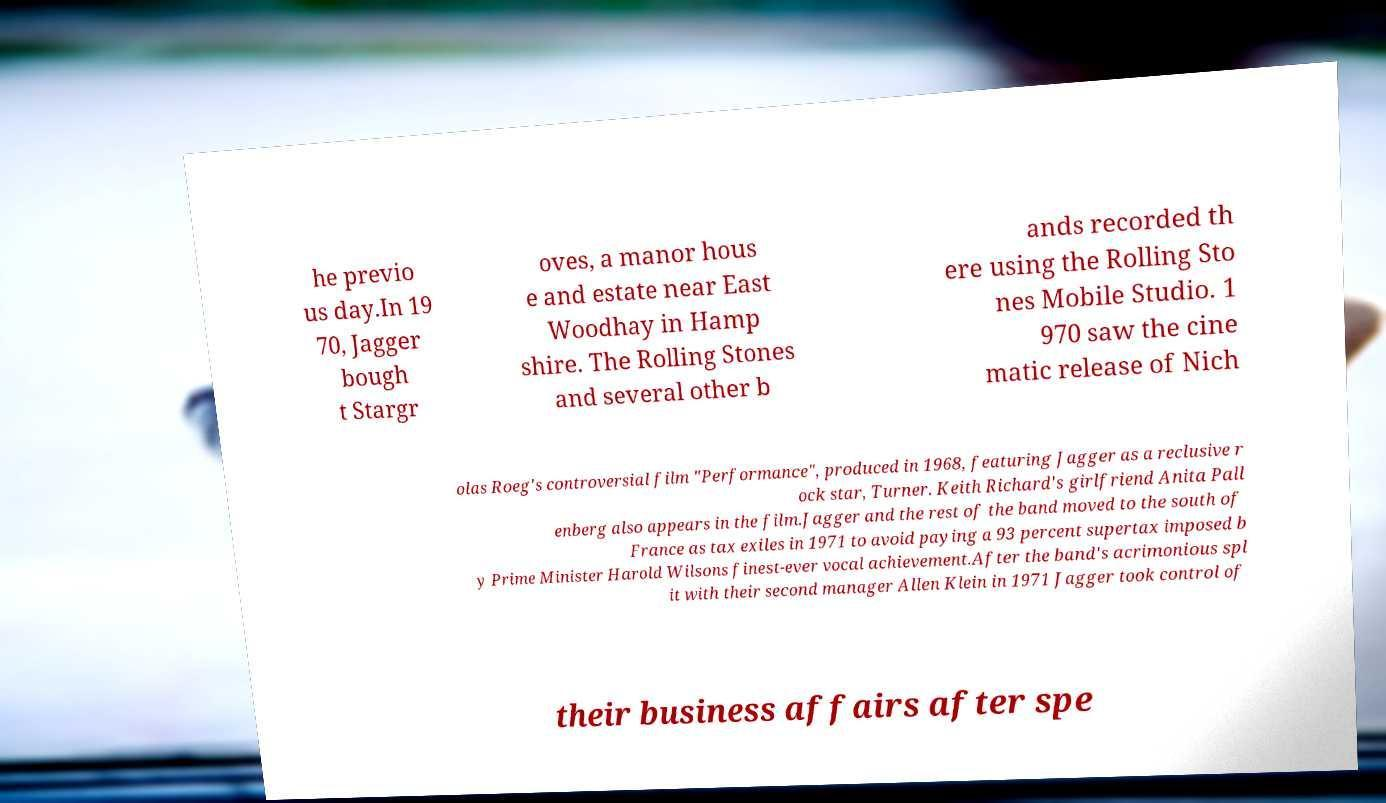Could you extract and type out the text from this image? he previo us day.In 19 70, Jagger bough t Stargr oves, a manor hous e and estate near East Woodhay in Hamp shire. The Rolling Stones and several other b ands recorded th ere using the Rolling Sto nes Mobile Studio. 1 970 saw the cine matic release of Nich olas Roeg's controversial film "Performance", produced in 1968, featuring Jagger as a reclusive r ock star, Turner. Keith Richard's girlfriend Anita Pall enberg also appears in the film.Jagger and the rest of the band moved to the south of France as tax exiles in 1971 to avoid paying a 93 percent supertax imposed b y Prime Minister Harold Wilsons finest-ever vocal achievement.After the band's acrimonious spl it with their second manager Allen Klein in 1971 Jagger took control of their business affairs after spe 